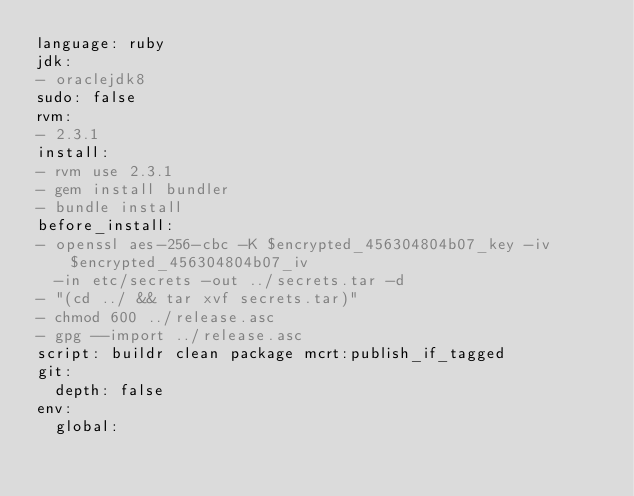<code> <loc_0><loc_0><loc_500><loc_500><_YAML_>language: ruby
jdk:
- oraclejdk8
sudo: false
rvm:
- 2.3.1
install:
- rvm use 2.3.1
- gem install bundler
- bundle install
before_install:
- openssl aes-256-cbc -K $encrypted_456304804b07_key -iv $encrypted_456304804b07_iv
  -in etc/secrets -out ../secrets.tar -d
- "(cd ../ && tar xvf secrets.tar)"
- chmod 600 ../release.asc
- gpg --import ../release.asc
script: buildr clean package mcrt:publish_if_tagged
git:
  depth: false
env:
  global:</code> 